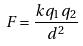Convert formula to latex. <formula><loc_0><loc_0><loc_500><loc_500>F = \frac { k q _ { 1 } q _ { 2 } } { d ^ { 2 } }</formula> 